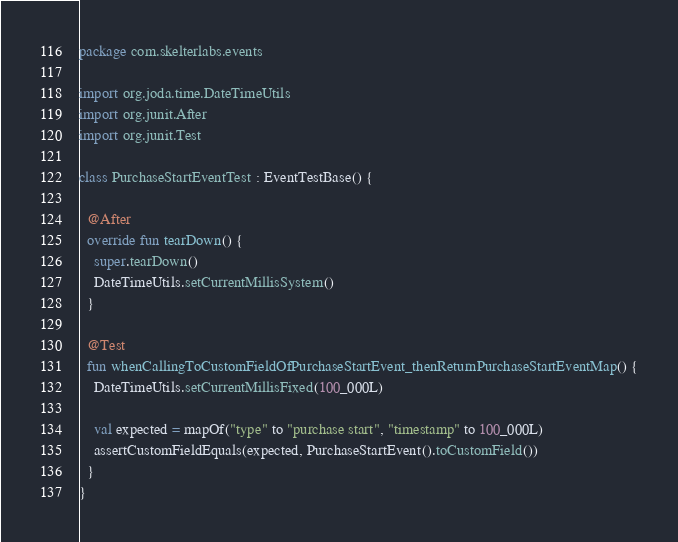Convert code to text. <code><loc_0><loc_0><loc_500><loc_500><_Kotlin_>package com.skelterlabs.events

import org.joda.time.DateTimeUtils
import org.junit.After
import org.junit.Test

class PurchaseStartEventTest : EventTestBase() {

  @After
  override fun tearDown() {
    super.tearDown()
    DateTimeUtils.setCurrentMillisSystem()
  }

  @Test
  fun whenCallingToCustomFieldOfPurchaseStartEvent_thenReturnPurchaseStartEventMap() {
    DateTimeUtils.setCurrentMillisFixed(100_000L)

    val expected = mapOf("type" to "purchase start", "timestamp" to 100_000L)
    assertCustomFieldEquals(expected, PurchaseStartEvent().toCustomField())
  }
}
</code> 